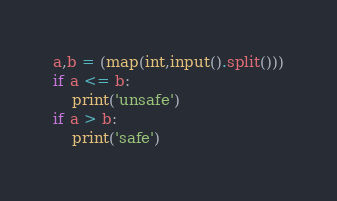Convert code to text. <code><loc_0><loc_0><loc_500><loc_500><_Python_>a,b = (map(int,input().split()))
if a <= b:
    print('unsafe')
if a > b:
    print('safe')</code> 